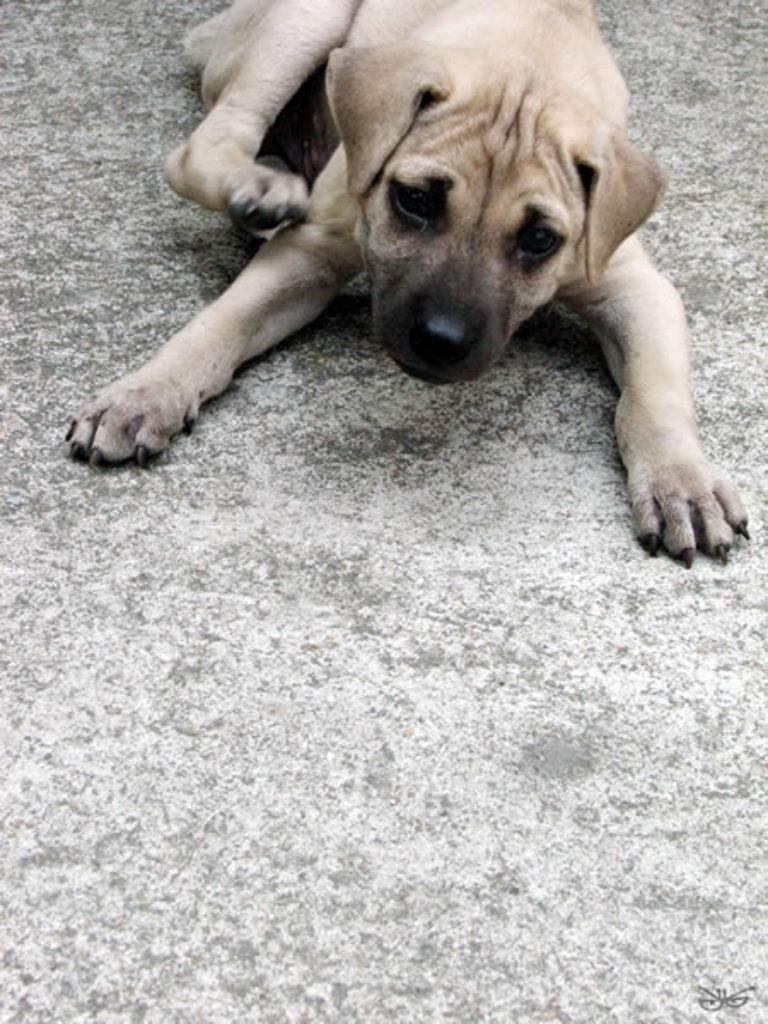What type of animal is present in the image? There is a dog in the image. Where is the dog located in the image? The dog is on the surface. What is the purpose of the mailbox in the image? There is no mailbox present in the image. Where can the dog be found eating lunch in the image? There is no indication of the dog eating lunch in the image. 